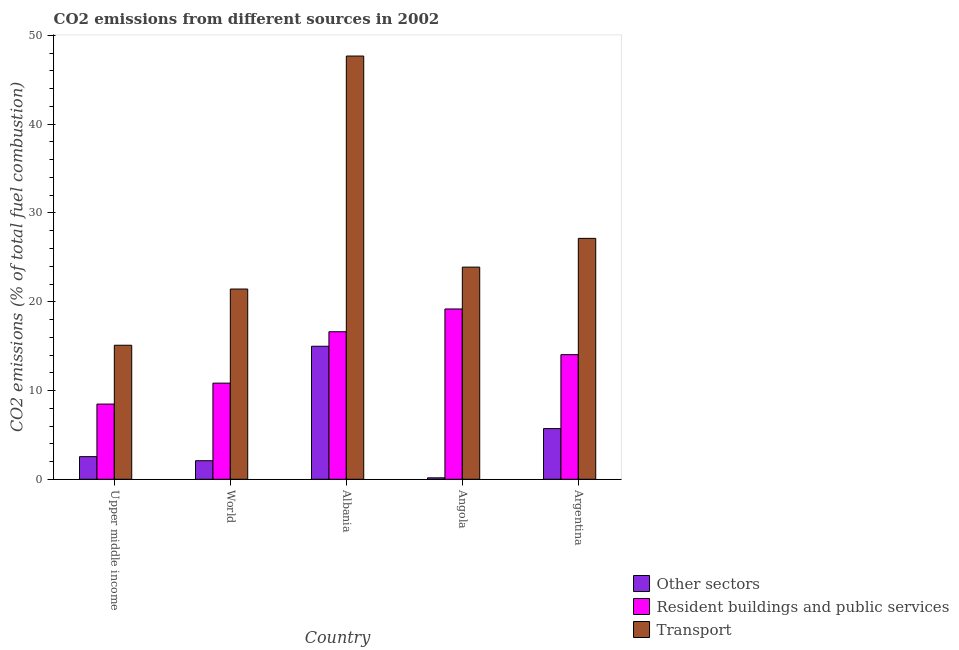How many different coloured bars are there?
Your response must be concise. 3. How many groups of bars are there?
Your answer should be very brief. 5. Are the number of bars on each tick of the X-axis equal?
Your answer should be very brief. Yes. What is the label of the 1st group of bars from the left?
Provide a succinct answer. Upper middle income. In how many cases, is the number of bars for a given country not equal to the number of legend labels?
Your answer should be very brief. 0. What is the percentage of co2 emissions from other sectors in Angola?
Ensure brevity in your answer.  0.16. Across all countries, what is the maximum percentage of co2 emissions from transport?
Ensure brevity in your answer.  47.68. Across all countries, what is the minimum percentage of co2 emissions from resident buildings and public services?
Your answer should be very brief. 8.47. In which country was the percentage of co2 emissions from other sectors maximum?
Provide a short and direct response. Albania. In which country was the percentage of co2 emissions from transport minimum?
Provide a short and direct response. Upper middle income. What is the total percentage of co2 emissions from transport in the graph?
Offer a very short reply. 135.26. What is the difference between the percentage of co2 emissions from resident buildings and public services in Angola and that in World?
Offer a terse response. 8.35. What is the difference between the percentage of co2 emissions from other sectors in Angola and the percentage of co2 emissions from transport in Albania?
Offer a very short reply. -47.52. What is the average percentage of co2 emissions from other sectors per country?
Make the answer very short. 5.1. What is the difference between the percentage of co2 emissions from transport and percentage of co2 emissions from resident buildings and public services in Upper middle income?
Keep it short and to the point. 6.63. What is the ratio of the percentage of co2 emissions from resident buildings and public services in Angola to that in World?
Your answer should be compact. 1.77. Is the percentage of co2 emissions from resident buildings and public services in Albania less than that in Argentina?
Your response must be concise. No. Is the difference between the percentage of co2 emissions from transport in Albania and Upper middle income greater than the difference between the percentage of co2 emissions from other sectors in Albania and Upper middle income?
Give a very brief answer. Yes. What is the difference between the highest and the second highest percentage of co2 emissions from resident buildings and public services?
Keep it short and to the point. 2.57. What is the difference between the highest and the lowest percentage of co2 emissions from transport?
Make the answer very short. 32.58. In how many countries, is the percentage of co2 emissions from resident buildings and public services greater than the average percentage of co2 emissions from resident buildings and public services taken over all countries?
Your answer should be compact. 3. Is the sum of the percentage of co2 emissions from other sectors in Argentina and World greater than the maximum percentage of co2 emissions from resident buildings and public services across all countries?
Keep it short and to the point. No. What does the 3rd bar from the left in Argentina represents?
Provide a short and direct response. Transport. What does the 3rd bar from the right in Argentina represents?
Make the answer very short. Other sectors. Are all the bars in the graph horizontal?
Provide a succinct answer. No. What is the difference between two consecutive major ticks on the Y-axis?
Offer a very short reply. 10. Are the values on the major ticks of Y-axis written in scientific E-notation?
Make the answer very short. No. Does the graph contain grids?
Keep it short and to the point. No. Where does the legend appear in the graph?
Offer a terse response. Bottom right. What is the title of the graph?
Make the answer very short. CO2 emissions from different sources in 2002. Does "Self-employed" appear as one of the legend labels in the graph?
Your answer should be compact. No. What is the label or title of the X-axis?
Your response must be concise. Country. What is the label or title of the Y-axis?
Your answer should be compact. CO2 emissions (% of total fuel combustion). What is the CO2 emissions (% of total fuel combustion) in Other sectors in Upper middle income?
Keep it short and to the point. 2.55. What is the CO2 emissions (% of total fuel combustion) of Resident buildings and public services in Upper middle income?
Your answer should be very brief. 8.47. What is the CO2 emissions (% of total fuel combustion) in Transport in Upper middle income?
Your answer should be very brief. 15.1. What is the CO2 emissions (% of total fuel combustion) of Other sectors in World?
Provide a short and direct response. 2.09. What is the CO2 emissions (% of total fuel combustion) in Resident buildings and public services in World?
Ensure brevity in your answer.  10.83. What is the CO2 emissions (% of total fuel combustion) in Transport in World?
Ensure brevity in your answer.  21.43. What is the CO2 emissions (% of total fuel combustion) of Other sectors in Albania?
Offer a very short reply. 14.99. What is the CO2 emissions (% of total fuel combustion) of Resident buildings and public services in Albania?
Your response must be concise. 16.62. What is the CO2 emissions (% of total fuel combustion) of Transport in Albania?
Keep it short and to the point. 47.68. What is the CO2 emissions (% of total fuel combustion) in Other sectors in Angola?
Give a very brief answer. 0.16. What is the CO2 emissions (% of total fuel combustion) in Resident buildings and public services in Angola?
Offer a very short reply. 19.19. What is the CO2 emissions (% of total fuel combustion) in Transport in Angola?
Your answer should be compact. 23.9. What is the CO2 emissions (% of total fuel combustion) of Other sectors in Argentina?
Offer a very short reply. 5.71. What is the CO2 emissions (% of total fuel combustion) of Resident buildings and public services in Argentina?
Offer a terse response. 14.04. What is the CO2 emissions (% of total fuel combustion) of Transport in Argentina?
Your answer should be compact. 27.14. Across all countries, what is the maximum CO2 emissions (% of total fuel combustion) in Other sectors?
Give a very brief answer. 14.99. Across all countries, what is the maximum CO2 emissions (% of total fuel combustion) in Resident buildings and public services?
Your answer should be compact. 19.19. Across all countries, what is the maximum CO2 emissions (% of total fuel combustion) in Transport?
Your response must be concise. 47.68. Across all countries, what is the minimum CO2 emissions (% of total fuel combustion) in Other sectors?
Offer a terse response. 0.16. Across all countries, what is the minimum CO2 emissions (% of total fuel combustion) in Resident buildings and public services?
Offer a very short reply. 8.47. Across all countries, what is the minimum CO2 emissions (% of total fuel combustion) in Transport?
Make the answer very short. 15.1. What is the total CO2 emissions (% of total fuel combustion) of Other sectors in the graph?
Your answer should be compact. 25.5. What is the total CO2 emissions (% of total fuel combustion) in Resident buildings and public services in the graph?
Your response must be concise. 69.15. What is the total CO2 emissions (% of total fuel combustion) in Transport in the graph?
Your answer should be compact. 135.26. What is the difference between the CO2 emissions (% of total fuel combustion) in Other sectors in Upper middle income and that in World?
Offer a very short reply. 0.46. What is the difference between the CO2 emissions (% of total fuel combustion) of Resident buildings and public services in Upper middle income and that in World?
Your response must be concise. -2.36. What is the difference between the CO2 emissions (% of total fuel combustion) in Transport in Upper middle income and that in World?
Your response must be concise. -6.33. What is the difference between the CO2 emissions (% of total fuel combustion) in Other sectors in Upper middle income and that in Albania?
Offer a terse response. -12.44. What is the difference between the CO2 emissions (% of total fuel combustion) in Resident buildings and public services in Upper middle income and that in Albania?
Ensure brevity in your answer.  -8.15. What is the difference between the CO2 emissions (% of total fuel combustion) of Transport in Upper middle income and that in Albania?
Offer a very short reply. -32.58. What is the difference between the CO2 emissions (% of total fuel combustion) of Other sectors in Upper middle income and that in Angola?
Your answer should be very brief. 2.39. What is the difference between the CO2 emissions (% of total fuel combustion) in Resident buildings and public services in Upper middle income and that in Angola?
Your answer should be very brief. -10.71. What is the difference between the CO2 emissions (% of total fuel combustion) in Transport in Upper middle income and that in Angola?
Your answer should be compact. -8.8. What is the difference between the CO2 emissions (% of total fuel combustion) in Other sectors in Upper middle income and that in Argentina?
Offer a terse response. -3.16. What is the difference between the CO2 emissions (% of total fuel combustion) in Resident buildings and public services in Upper middle income and that in Argentina?
Offer a very short reply. -5.57. What is the difference between the CO2 emissions (% of total fuel combustion) in Transport in Upper middle income and that in Argentina?
Keep it short and to the point. -12.04. What is the difference between the CO2 emissions (% of total fuel combustion) in Other sectors in World and that in Albania?
Your answer should be compact. -12.9. What is the difference between the CO2 emissions (% of total fuel combustion) in Resident buildings and public services in World and that in Albania?
Offer a very short reply. -5.79. What is the difference between the CO2 emissions (% of total fuel combustion) in Transport in World and that in Albania?
Your answer should be compact. -26.25. What is the difference between the CO2 emissions (% of total fuel combustion) of Other sectors in World and that in Angola?
Your response must be concise. 1.93. What is the difference between the CO2 emissions (% of total fuel combustion) of Resident buildings and public services in World and that in Angola?
Give a very brief answer. -8.36. What is the difference between the CO2 emissions (% of total fuel combustion) in Transport in World and that in Angola?
Provide a short and direct response. -2.47. What is the difference between the CO2 emissions (% of total fuel combustion) of Other sectors in World and that in Argentina?
Provide a short and direct response. -3.62. What is the difference between the CO2 emissions (% of total fuel combustion) of Resident buildings and public services in World and that in Argentina?
Offer a terse response. -3.21. What is the difference between the CO2 emissions (% of total fuel combustion) in Transport in World and that in Argentina?
Make the answer very short. -5.71. What is the difference between the CO2 emissions (% of total fuel combustion) in Other sectors in Albania and that in Angola?
Your response must be concise. 14.82. What is the difference between the CO2 emissions (% of total fuel combustion) in Resident buildings and public services in Albania and that in Angola?
Give a very brief answer. -2.57. What is the difference between the CO2 emissions (% of total fuel combustion) of Transport in Albania and that in Angola?
Your answer should be compact. 23.78. What is the difference between the CO2 emissions (% of total fuel combustion) of Other sectors in Albania and that in Argentina?
Provide a succinct answer. 9.28. What is the difference between the CO2 emissions (% of total fuel combustion) in Resident buildings and public services in Albania and that in Argentina?
Make the answer very short. 2.58. What is the difference between the CO2 emissions (% of total fuel combustion) in Transport in Albania and that in Argentina?
Your response must be concise. 20.54. What is the difference between the CO2 emissions (% of total fuel combustion) in Other sectors in Angola and that in Argentina?
Your answer should be compact. -5.55. What is the difference between the CO2 emissions (% of total fuel combustion) of Resident buildings and public services in Angola and that in Argentina?
Give a very brief answer. 5.15. What is the difference between the CO2 emissions (% of total fuel combustion) in Transport in Angola and that in Argentina?
Your answer should be very brief. -3.24. What is the difference between the CO2 emissions (% of total fuel combustion) in Other sectors in Upper middle income and the CO2 emissions (% of total fuel combustion) in Resident buildings and public services in World?
Your response must be concise. -8.28. What is the difference between the CO2 emissions (% of total fuel combustion) in Other sectors in Upper middle income and the CO2 emissions (% of total fuel combustion) in Transport in World?
Your answer should be compact. -18.88. What is the difference between the CO2 emissions (% of total fuel combustion) in Resident buildings and public services in Upper middle income and the CO2 emissions (% of total fuel combustion) in Transport in World?
Your answer should be compact. -12.96. What is the difference between the CO2 emissions (% of total fuel combustion) in Other sectors in Upper middle income and the CO2 emissions (% of total fuel combustion) in Resident buildings and public services in Albania?
Your answer should be very brief. -14.07. What is the difference between the CO2 emissions (% of total fuel combustion) in Other sectors in Upper middle income and the CO2 emissions (% of total fuel combustion) in Transport in Albania?
Your response must be concise. -45.14. What is the difference between the CO2 emissions (% of total fuel combustion) of Resident buildings and public services in Upper middle income and the CO2 emissions (% of total fuel combustion) of Transport in Albania?
Offer a very short reply. -39.21. What is the difference between the CO2 emissions (% of total fuel combustion) in Other sectors in Upper middle income and the CO2 emissions (% of total fuel combustion) in Resident buildings and public services in Angola?
Your answer should be compact. -16.64. What is the difference between the CO2 emissions (% of total fuel combustion) of Other sectors in Upper middle income and the CO2 emissions (% of total fuel combustion) of Transport in Angola?
Make the answer very short. -21.35. What is the difference between the CO2 emissions (% of total fuel combustion) of Resident buildings and public services in Upper middle income and the CO2 emissions (% of total fuel combustion) of Transport in Angola?
Your answer should be very brief. -15.43. What is the difference between the CO2 emissions (% of total fuel combustion) of Other sectors in Upper middle income and the CO2 emissions (% of total fuel combustion) of Resident buildings and public services in Argentina?
Your answer should be compact. -11.49. What is the difference between the CO2 emissions (% of total fuel combustion) of Other sectors in Upper middle income and the CO2 emissions (% of total fuel combustion) of Transport in Argentina?
Your answer should be compact. -24.59. What is the difference between the CO2 emissions (% of total fuel combustion) in Resident buildings and public services in Upper middle income and the CO2 emissions (% of total fuel combustion) in Transport in Argentina?
Make the answer very short. -18.67. What is the difference between the CO2 emissions (% of total fuel combustion) in Other sectors in World and the CO2 emissions (% of total fuel combustion) in Resident buildings and public services in Albania?
Your answer should be very brief. -14.53. What is the difference between the CO2 emissions (% of total fuel combustion) of Other sectors in World and the CO2 emissions (% of total fuel combustion) of Transport in Albania?
Offer a terse response. -45.59. What is the difference between the CO2 emissions (% of total fuel combustion) in Resident buildings and public services in World and the CO2 emissions (% of total fuel combustion) in Transport in Albania?
Keep it short and to the point. -36.85. What is the difference between the CO2 emissions (% of total fuel combustion) of Other sectors in World and the CO2 emissions (% of total fuel combustion) of Resident buildings and public services in Angola?
Your answer should be compact. -17.1. What is the difference between the CO2 emissions (% of total fuel combustion) in Other sectors in World and the CO2 emissions (% of total fuel combustion) in Transport in Angola?
Provide a succinct answer. -21.81. What is the difference between the CO2 emissions (% of total fuel combustion) of Resident buildings and public services in World and the CO2 emissions (% of total fuel combustion) of Transport in Angola?
Your answer should be very brief. -13.07. What is the difference between the CO2 emissions (% of total fuel combustion) in Other sectors in World and the CO2 emissions (% of total fuel combustion) in Resident buildings and public services in Argentina?
Provide a short and direct response. -11.95. What is the difference between the CO2 emissions (% of total fuel combustion) of Other sectors in World and the CO2 emissions (% of total fuel combustion) of Transport in Argentina?
Provide a succinct answer. -25.05. What is the difference between the CO2 emissions (% of total fuel combustion) in Resident buildings and public services in World and the CO2 emissions (% of total fuel combustion) in Transport in Argentina?
Give a very brief answer. -16.31. What is the difference between the CO2 emissions (% of total fuel combustion) in Other sectors in Albania and the CO2 emissions (% of total fuel combustion) in Resident buildings and public services in Angola?
Your answer should be very brief. -4.2. What is the difference between the CO2 emissions (% of total fuel combustion) in Other sectors in Albania and the CO2 emissions (% of total fuel combustion) in Transport in Angola?
Offer a terse response. -8.92. What is the difference between the CO2 emissions (% of total fuel combustion) of Resident buildings and public services in Albania and the CO2 emissions (% of total fuel combustion) of Transport in Angola?
Your answer should be compact. -7.28. What is the difference between the CO2 emissions (% of total fuel combustion) in Other sectors in Albania and the CO2 emissions (% of total fuel combustion) in Resident buildings and public services in Argentina?
Offer a very short reply. 0.95. What is the difference between the CO2 emissions (% of total fuel combustion) in Other sectors in Albania and the CO2 emissions (% of total fuel combustion) in Transport in Argentina?
Keep it short and to the point. -12.15. What is the difference between the CO2 emissions (% of total fuel combustion) in Resident buildings and public services in Albania and the CO2 emissions (% of total fuel combustion) in Transport in Argentina?
Your response must be concise. -10.52. What is the difference between the CO2 emissions (% of total fuel combustion) in Other sectors in Angola and the CO2 emissions (% of total fuel combustion) in Resident buildings and public services in Argentina?
Your answer should be very brief. -13.88. What is the difference between the CO2 emissions (% of total fuel combustion) of Other sectors in Angola and the CO2 emissions (% of total fuel combustion) of Transport in Argentina?
Give a very brief answer. -26.98. What is the difference between the CO2 emissions (% of total fuel combustion) in Resident buildings and public services in Angola and the CO2 emissions (% of total fuel combustion) in Transport in Argentina?
Give a very brief answer. -7.95. What is the average CO2 emissions (% of total fuel combustion) in Other sectors per country?
Provide a short and direct response. 5.1. What is the average CO2 emissions (% of total fuel combustion) of Resident buildings and public services per country?
Your answer should be very brief. 13.83. What is the average CO2 emissions (% of total fuel combustion) in Transport per country?
Keep it short and to the point. 27.05. What is the difference between the CO2 emissions (% of total fuel combustion) of Other sectors and CO2 emissions (% of total fuel combustion) of Resident buildings and public services in Upper middle income?
Provide a short and direct response. -5.93. What is the difference between the CO2 emissions (% of total fuel combustion) of Other sectors and CO2 emissions (% of total fuel combustion) of Transport in Upper middle income?
Keep it short and to the point. -12.55. What is the difference between the CO2 emissions (% of total fuel combustion) in Resident buildings and public services and CO2 emissions (% of total fuel combustion) in Transport in Upper middle income?
Your response must be concise. -6.63. What is the difference between the CO2 emissions (% of total fuel combustion) in Other sectors and CO2 emissions (% of total fuel combustion) in Resident buildings and public services in World?
Offer a terse response. -8.74. What is the difference between the CO2 emissions (% of total fuel combustion) in Other sectors and CO2 emissions (% of total fuel combustion) in Transport in World?
Offer a terse response. -19.34. What is the difference between the CO2 emissions (% of total fuel combustion) of Resident buildings and public services and CO2 emissions (% of total fuel combustion) of Transport in World?
Ensure brevity in your answer.  -10.6. What is the difference between the CO2 emissions (% of total fuel combustion) in Other sectors and CO2 emissions (% of total fuel combustion) in Resident buildings and public services in Albania?
Give a very brief answer. -1.63. What is the difference between the CO2 emissions (% of total fuel combustion) of Other sectors and CO2 emissions (% of total fuel combustion) of Transport in Albania?
Offer a terse response. -32.7. What is the difference between the CO2 emissions (% of total fuel combustion) of Resident buildings and public services and CO2 emissions (% of total fuel combustion) of Transport in Albania?
Give a very brief answer. -31.06. What is the difference between the CO2 emissions (% of total fuel combustion) in Other sectors and CO2 emissions (% of total fuel combustion) in Resident buildings and public services in Angola?
Keep it short and to the point. -19.02. What is the difference between the CO2 emissions (% of total fuel combustion) in Other sectors and CO2 emissions (% of total fuel combustion) in Transport in Angola?
Keep it short and to the point. -23.74. What is the difference between the CO2 emissions (% of total fuel combustion) in Resident buildings and public services and CO2 emissions (% of total fuel combustion) in Transport in Angola?
Make the answer very short. -4.72. What is the difference between the CO2 emissions (% of total fuel combustion) in Other sectors and CO2 emissions (% of total fuel combustion) in Resident buildings and public services in Argentina?
Keep it short and to the point. -8.33. What is the difference between the CO2 emissions (% of total fuel combustion) of Other sectors and CO2 emissions (% of total fuel combustion) of Transport in Argentina?
Make the answer very short. -21.43. What is the difference between the CO2 emissions (% of total fuel combustion) of Resident buildings and public services and CO2 emissions (% of total fuel combustion) of Transport in Argentina?
Make the answer very short. -13.1. What is the ratio of the CO2 emissions (% of total fuel combustion) in Other sectors in Upper middle income to that in World?
Ensure brevity in your answer.  1.22. What is the ratio of the CO2 emissions (% of total fuel combustion) of Resident buildings and public services in Upper middle income to that in World?
Offer a very short reply. 0.78. What is the ratio of the CO2 emissions (% of total fuel combustion) of Transport in Upper middle income to that in World?
Ensure brevity in your answer.  0.7. What is the ratio of the CO2 emissions (% of total fuel combustion) in Other sectors in Upper middle income to that in Albania?
Your answer should be compact. 0.17. What is the ratio of the CO2 emissions (% of total fuel combustion) in Resident buildings and public services in Upper middle income to that in Albania?
Make the answer very short. 0.51. What is the ratio of the CO2 emissions (% of total fuel combustion) in Transport in Upper middle income to that in Albania?
Give a very brief answer. 0.32. What is the ratio of the CO2 emissions (% of total fuel combustion) in Other sectors in Upper middle income to that in Angola?
Your answer should be compact. 15.67. What is the ratio of the CO2 emissions (% of total fuel combustion) of Resident buildings and public services in Upper middle income to that in Angola?
Provide a succinct answer. 0.44. What is the ratio of the CO2 emissions (% of total fuel combustion) of Transport in Upper middle income to that in Angola?
Provide a short and direct response. 0.63. What is the ratio of the CO2 emissions (% of total fuel combustion) of Other sectors in Upper middle income to that in Argentina?
Provide a short and direct response. 0.45. What is the ratio of the CO2 emissions (% of total fuel combustion) in Resident buildings and public services in Upper middle income to that in Argentina?
Provide a succinct answer. 0.6. What is the ratio of the CO2 emissions (% of total fuel combustion) of Transport in Upper middle income to that in Argentina?
Keep it short and to the point. 0.56. What is the ratio of the CO2 emissions (% of total fuel combustion) in Other sectors in World to that in Albania?
Ensure brevity in your answer.  0.14. What is the ratio of the CO2 emissions (% of total fuel combustion) in Resident buildings and public services in World to that in Albania?
Your response must be concise. 0.65. What is the ratio of the CO2 emissions (% of total fuel combustion) in Transport in World to that in Albania?
Offer a terse response. 0.45. What is the ratio of the CO2 emissions (% of total fuel combustion) of Other sectors in World to that in Angola?
Provide a short and direct response. 12.86. What is the ratio of the CO2 emissions (% of total fuel combustion) in Resident buildings and public services in World to that in Angola?
Your answer should be compact. 0.56. What is the ratio of the CO2 emissions (% of total fuel combustion) in Transport in World to that in Angola?
Make the answer very short. 0.9. What is the ratio of the CO2 emissions (% of total fuel combustion) of Other sectors in World to that in Argentina?
Offer a very short reply. 0.37. What is the ratio of the CO2 emissions (% of total fuel combustion) in Resident buildings and public services in World to that in Argentina?
Your response must be concise. 0.77. What is the ratio of the CO2 emissions (% of total fuel combustion) of Transport in World to that in Argentina?
Provide a succinct answer. 0.79. What is the ratio of the CO2 emissions (% of total fuel combustion) in Other sectors in Albania to that in Angola?
Ensure brevity in your answer.  92.17. What is the ratio of the CO2 emissions (% of total fuel combustion) of Resident buildings and public services in Albania to that in Angola?
Keep it short and to the point. 0.87. What is the ratio of the CO2 emissions (% of total fuel combustion) in Transport in Albania to that in Angola?
Provide a short and direct response. 1.99. What is the ratio of the CO2 emissions (% of total fuel combustion) in Other sectors in Albania to that in Argentina?
Offer a very short reply. 2.62. What is the ratio of the CO2 emissions (% of total fuel combustion) in Resident buildings and public services in Albania to that in Argentina?
Provide a succinct answer. 1.18. What is the ratio of the CO2 emissions (% of total fuel combustion) of Transport in Albania to that in Argentina?
Your response must be concise. 1.76. What is the ratio of the CO2 emissions (% of total fuel combustion) of Other sectors in Angola to that in Argentina?
Give a very brief answer. 0.03. What is the ratio of the CO2 emissions (% of total fuel combustion) of Resident buildings and public services in Angola to that in Argentina?
Your answer should be compact. 1.37. What is the ratio of the CO2 emissions (% of total fuel combustion) in Transport in Angola to that in Argentina?
Offer a very short reply. 0.88. What is the difference between the highest and the second highest CO2 emissions (% of total fuel combustion) of Other sectors?
Your answer should be compact. 9.28. What is the difference between the highest and the second highest CO2 emissions (% of total fuel combustion) of Resident buildings and public services?
Offer a terse response. 2.57. What is the difference between the highest and the second highest CO2 emissions (% of total fuel combustion) of Transport?
Give a very brief answer. 20.54. What is the difference between the highest and the lowest CO2 emissions (% of total fuel combustion) in Other sectors?
Offer a terse response. 14.82. What is the difference between the highest and the lowest CO2 emissions (% of total fuel combustion) in Resident buildings and public services?
Your response must be concise. 10.71. What is the difference between the highest and the lowest CO2 emissions (% of total fuel combustion) in Transport?
Offer a very short reply. 32.58. 